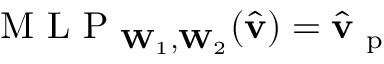<formula> <loc_0><loc_0><loc_500><loc_500>M L P _ { W _ { 1 } , W _ { 2 } } ( \hat { v } ) = \hat { v } _ { p }</formula> 